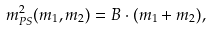Convert formula to latex. <formula><loc_0><loc_0><loc_500><loc_500>m _ { P S } ^ { 2 } ( m _ { 1 } , m _ { 2 } ) = B \cdot ( m _ { 1 } + m _ { 2 } ) ,</formula> 